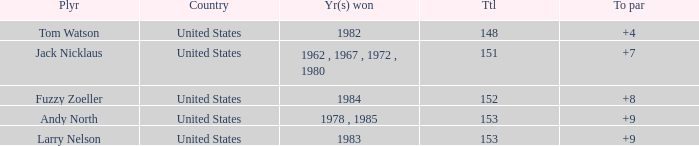What is the Total of the Player with a Year(s) won of 1982? 148.0. 